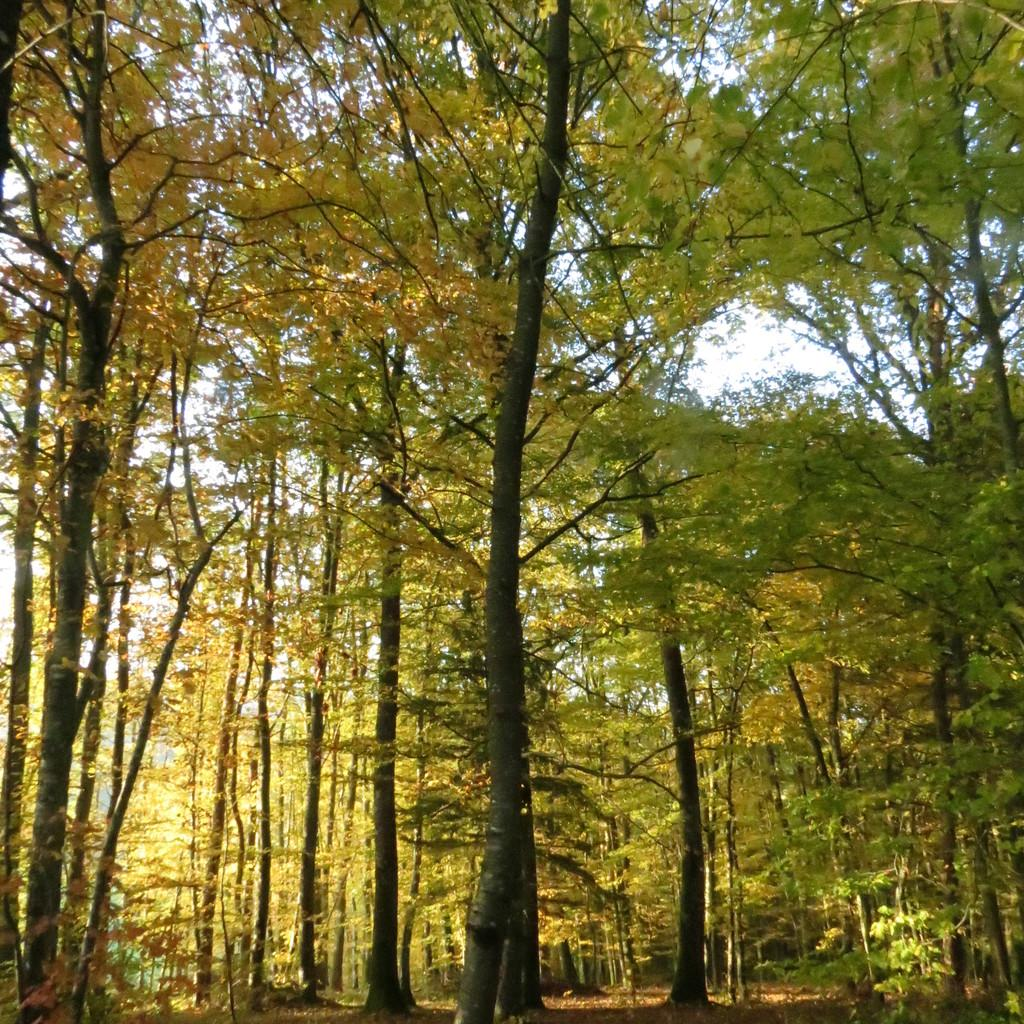What type of vegetation can be seen in the image? There are trees in the image. Can you describe the trees in the image? The provided facts do not give specific details about the trees, so we cannot describe them further. What might be the purpose of the trees in the image? The trees in the image could provide shade, serve as a natural barrier, or simply be part of the landscape. What type of furniture can be smelled in the image? There is no furniture present in the image, and therefore no scent can be associated with it. 